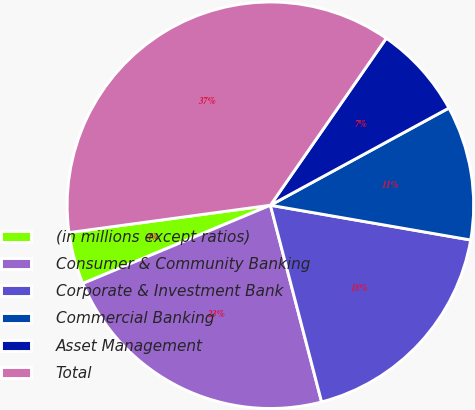Convert chart. <chart><loc_0><loc_0><loc_500><loc_500><pie_chart><fcel>(in millions except ratios)<fcel>Consumer & Community Banking<fcel>Corporate & Investment Bank<fcel>Commercial Banking<fcel>Asset Management<fcel>Total<nl><fcel>4.14%<fcel>22.76%<fcel>18.21%<fcel>10.67%<fcel>7.41%<fcel>36.8%<nl></chart> 